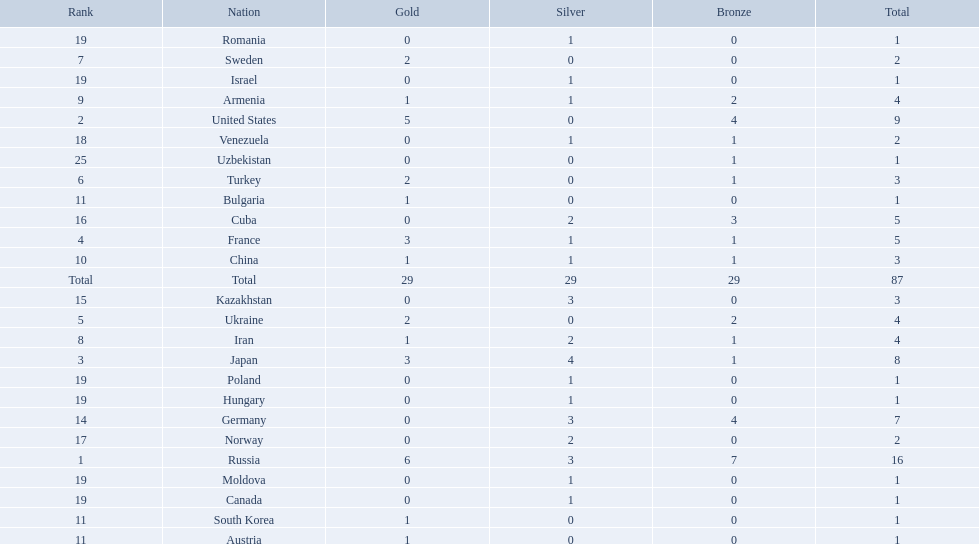Parse the table in full. {'header': ['Rank', 'Nation', 'Gold', 'Silver', 'Bronze', 'Total'], 'rows': [['19', 'Romania', '0', '1', '0', '1'], ['7', 'Sweden', '2', '0', '0', '2'], ['19', 'Israel', '0', '1', '0', '1'], ['9', 'Armenia', '1', '1', '2', '4'], ['2', 'United States', '5', '0', '4', '9'], ['18', 'Venezuela', '0', '1', '1', '2'], ['25', 'Uzbekistan', '0', '0', '1', '1'], ['6', 'Turkey', '2', '0', '1', '3'], ['11', 'Bulgaria', '1', '0', '0', '1'], ['16', 'Cuba', '0', '2', '3', '5'], ['4', 'France', '3', '1', '1', '5'], ['10', 'China', '1', '1', '1', '3'], ['Total', 'Total', '29', '29', '29', '87'], ['15', 'Kazakhstan', '0', '3', '0', '3'], ['5', 'Ukraine', '2', '0', '2', '4'], ['8', 'Iran', '1', '2', '1', '4'], ['3', 'Japan', '3', '4', '1', '8'], ['19', 'Poland', '0', '1', '0', '1'], ['19', 'Hungary', '0', '1', '0', '1'], ['14', 'Germany', '0', '3', '4', '7'], ['17', 'Norway', '0', '2', '0', '2'], ['1', 'Russia', '6', '3', '7', '16'], ['19', 'Moldova', '0', '1', '0', '1'], ['19', 'Canada', '0', '1', '0', '1'], ['11', 'South Korea', '1', '0', '0', '1'], ['11', 'Austria', '1', '0', '0', '1']]} How many silver medals did turkey win? 0. 